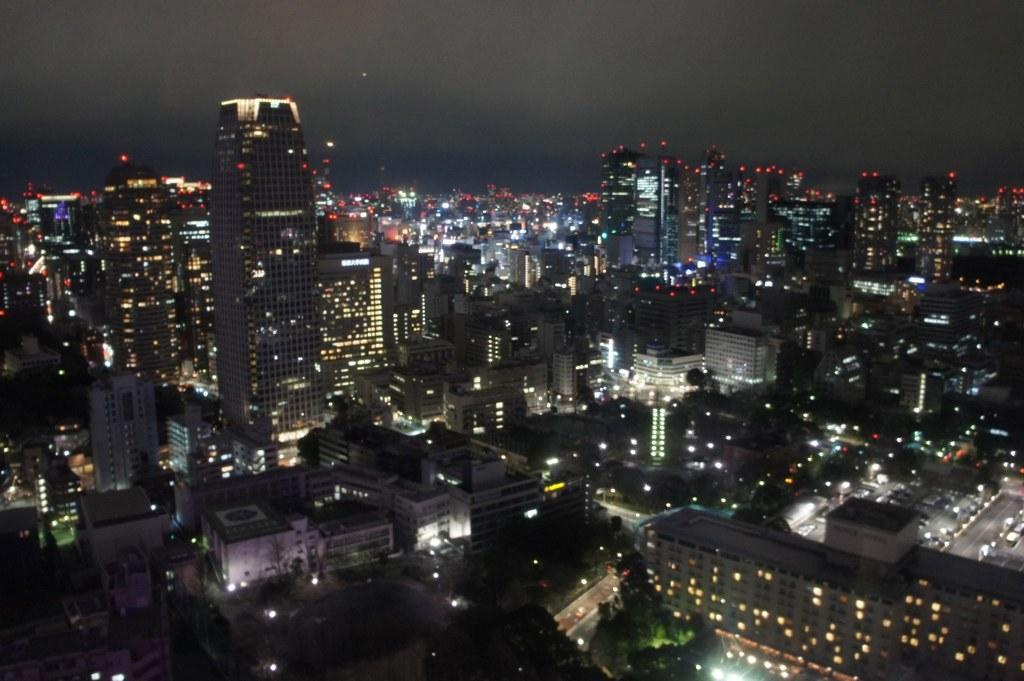What is the main subject of the image? The main subject of the image is a group of buildings. What features can be observed on the buildings? The buildings have windows, and some lights are visible on them. What is present in the foreground of the image? There are trees in the foreground of the image. What is visible at the top of the image? The sky is visible at the top of the image. What type of island can be seen in the image? There is no island present in the image; it features a group of buildings with trees in the foreground and the sky visible at the top. What kind of polish is being applied to the buildings in the image? There is no indication of any polish being applied to the buildings in the image. 